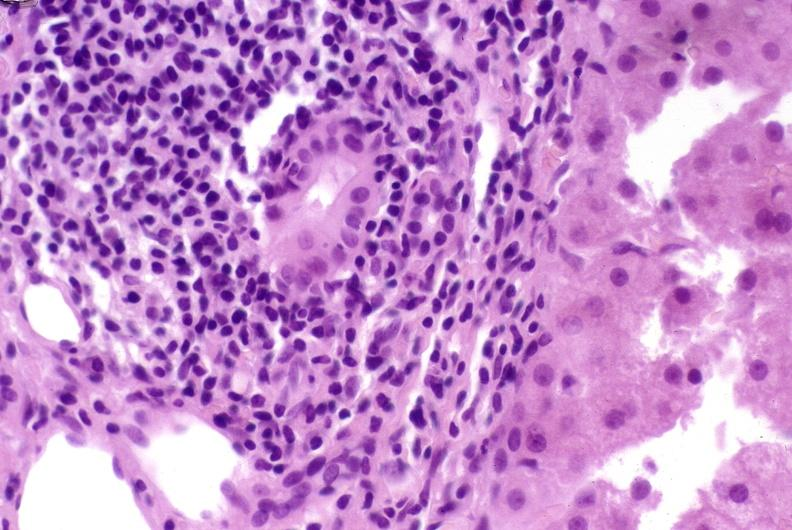s hepatobiliary present?
Answer the question using a single word or phrase. Yes 